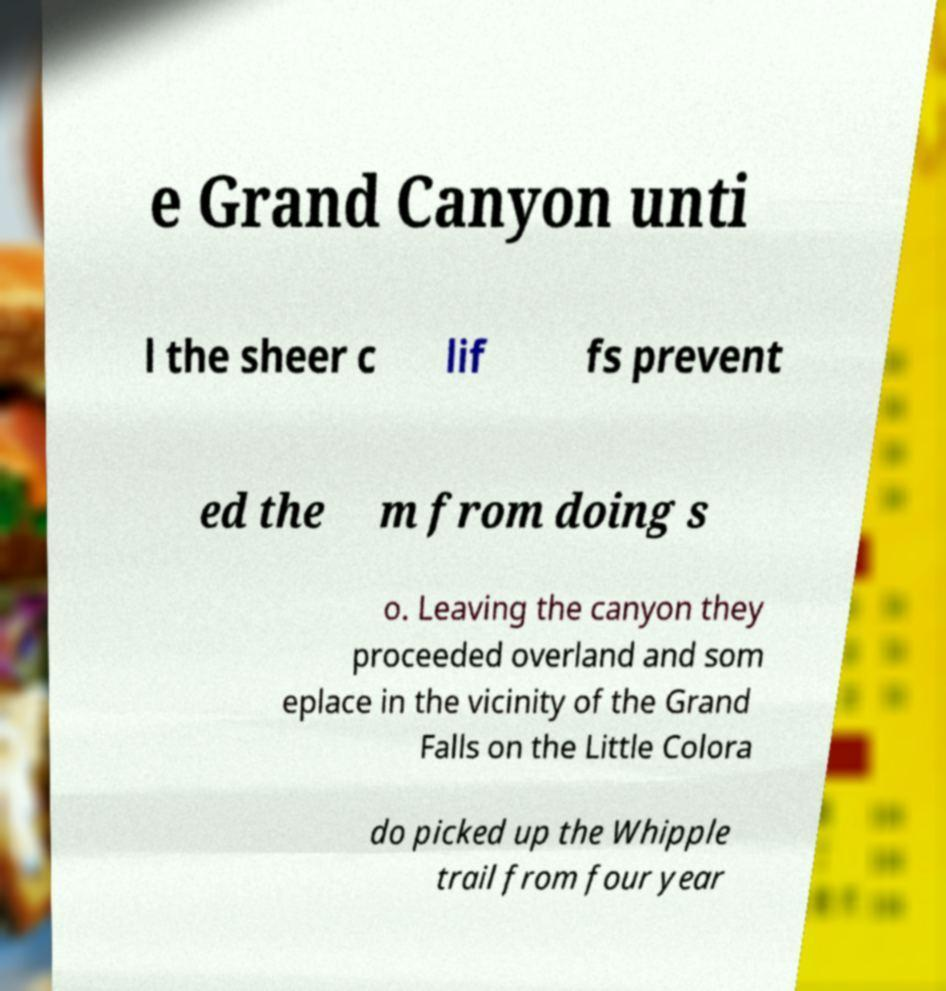For documentation purposes, I need the text within this image transcribed. Could you provide that? e Grand Canyon unti l the sheer c lif fs prevent ed the m from doing s o. Leaving the canyon they proceeded overland and som eplace in the vicinity of the Grand Falls on the Little Colora do picked up the Whipple trail from four year 